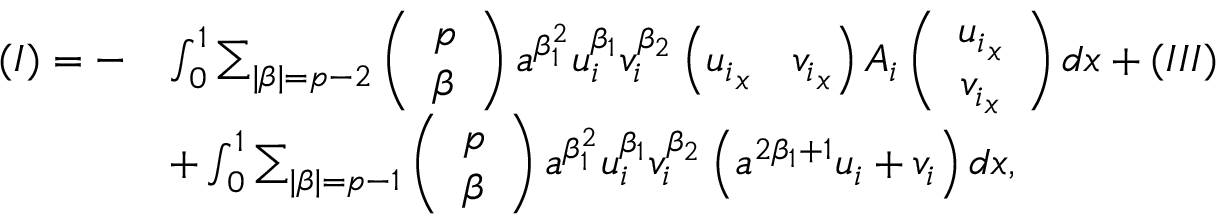<formula> <loc_0><loc_0><loc_500><loc_500>\begin{array} { r l } { ( I ) = - } & { \int _ { 0 } ^ { 1 } \sum _ { | \beta | = p - 2 } \left ( \begin{array} { l } { p } \\ { \beta } \end{array} \right ) a ^ { \beta _ { 1 } ^ { 2 } } u _ { i } ^ { \beta _ { 1 } } v _ { i } ^ { \beta _ { 2 } } \left ( { u _ { i } } _ { x } \quad v _ { i } _ { x } \right ) A _ { i } \left ( \begin{array} { c } { { u _ { i } } _ { x } } \\ { { v _ { i } } _ { x } } \end{array} \right ) d x + ( I I I ) } \\ & { + \int _ { 0 } ^ { 1 } \sum _ { | \beta | = p - 1 } \left ( \begin{array} { c } { p } \\ { \beta } \end{array} \right ) a ^ { \beta _ { 1 } ^ { 2 } } u _ { i } ^ { \beta _ { 1 } } v _ { i } ^ { \beta _ { 2 } } \left ( a ^ { 2 \beta _ { 1 } + 1 } { u _ { i } } + { v _ { i } } \right ) d x , } \end{array}</formula> 